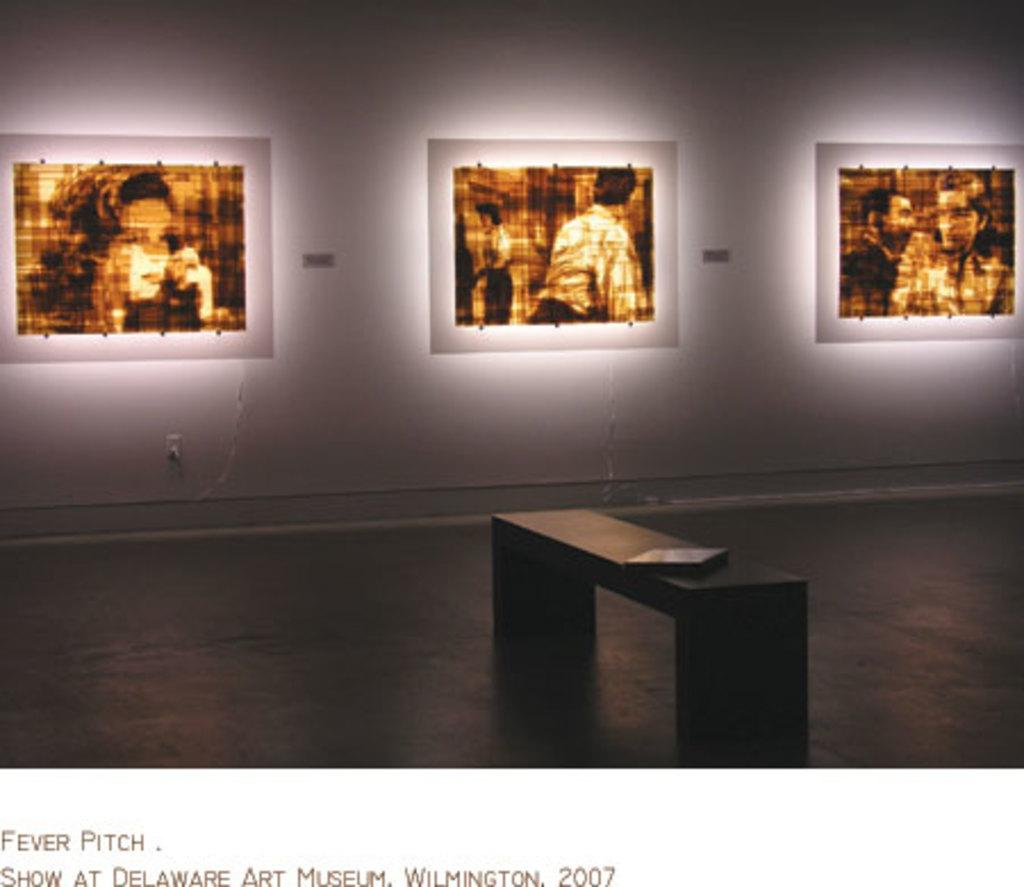What is located in the center of the image? There is a bench in the center of the image. What can be seen on the wall in the image? There are three images on the wall in the image. What type of wood is used to construct the bench in the image? The type of wood used to construct the bench is not mentioned or visible in the image. What advice can be seen in the images on the wall? There is no advice visible in the images on the wall; they are not text-based. 